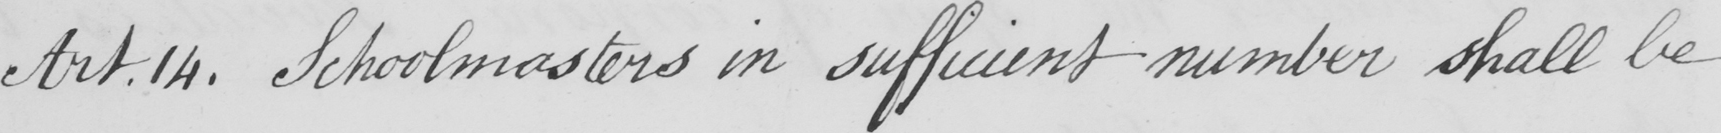What is written in this line of handwriting? Art . 14 . Schoolmasters in sufficient number shall be 